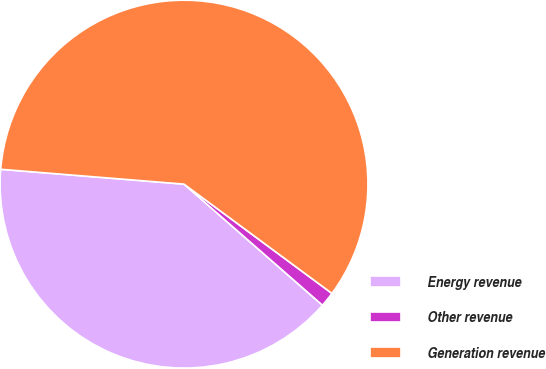Convert chart to OTSL. <chart><loc_0><loc_0><loc_500><loc_500><pie_chart><fcel>Energy revenue<fcel>Other revenue<fcel>Generation revenue<nl><fcel>39.85%<fcel>1.31%<fcel>58.84%<nl></chart> 